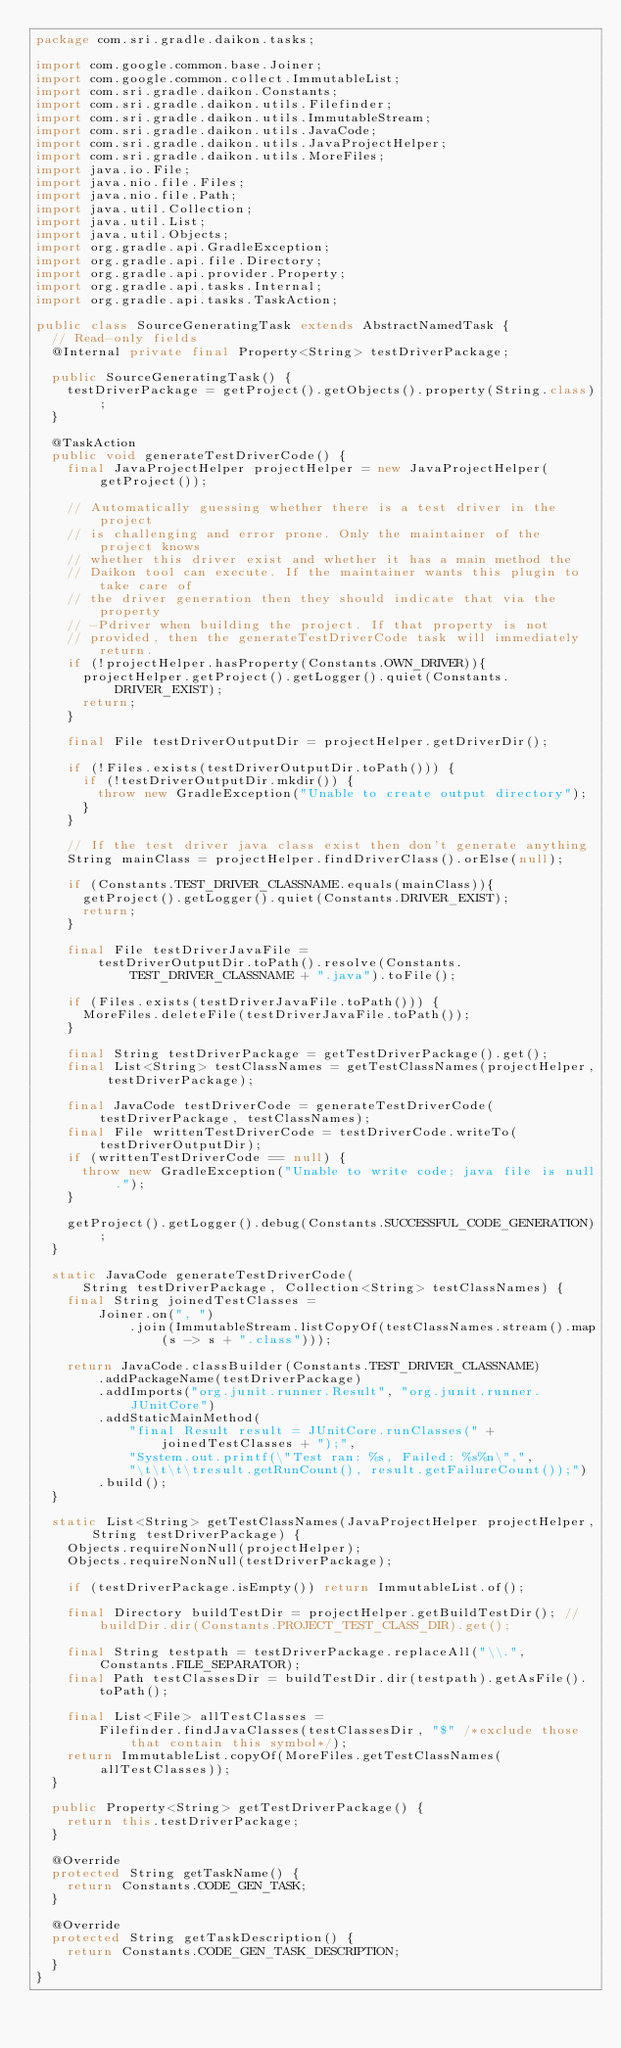<code> <loc_0><loc_0><loc_500><loc_500><_Java_>package com.sri.gradle.daikon.tasks;

import com.google.common.base.Joiner;
import com.google.common.collect.ImmutableList;
import com.sri.gradle.daikon.Constants;
import com.sri.gradle.daikon.utils.Filefinder;
import com.sri.gradle.daikon.utils.ImmutableStream;
import com.sri.gradle.daikon.utils.JavaCode;
import com.sri.gradle.daikon.utils.JavaProjectHelper;
import com.sri.gradle.daikon.utils.MoreFiles;
import java.io.File;
import java.nio.file.Files;
import java.nio.file.Path;
import java.util.Collection;
import java.util.List;
import java.util.Objects;
import org.gradle.api.GradleException;
import org.gradle.api.file.Directory;
import org.gradle.api.provider.Property;
import org.gradle.api.tasks.Internal;
import org.gradle.api.tasks.TaskAction;

public class SourceGeneratingTask extends AbstractNamedTask {
  // Read-only fields
  @Internal private final Property<String> testDriverPackage;

  public SourceGeneratingTask() {
    testDriverPackage = getProject().getObjects().property(String.class);
  }

  @TaskAction
  public void generateTestDriverCode() {
    final JavaProjectHelper projectHelper = new JavaProjectHelper(getProject());

    // Automatically guessing whether there is a test driver in the project
    // is challenging and error prone. Only the maintainer of the project knows
    // whether this driver exist and whether it has a main method the
    // Daikon tool can execute. If the maintainer wants this plugin to take care of
    // the driver generation then they should indicate that via the property
    // -Pdriver when building the project. If that property is not
    // provided, then the generateTestDriverCode task will immediately return.
    if (!projectHelper.hasProperty(Constants.OWN_DRIVER)){
      projectHelper.getProject().getLogger().quiet(Constants.DRIVER_EXIST);
      return;
    }

    final File testDriverOutputDir = projectHelper.getDriverDir();

    if (!Files.exists(testDriverOutputDir.toPath())) {
      if (!testDriverOutputDir.mkdir()) {
        throw new GradleException("Unable to create output directory");
      }
    }

    // If the test driver java class exist then don't generate anything
    String mainClass = projectHelper.findDriverClass().orElse(null);

    if (Constants.TEST_DRIVER_CLASSNAME.equals(mainClass)){
      getProject().getLogger().quiet(Constants.DRIVER_EXIST);
      return;
    }

    final File testDriverJavaFile =
        testDriverOutputDir.toPath().resolve(Constants.TEST_DRIVER_CLASSNAME + ".java").toFile();

    if (Files.exists(testDriverJavaFile.toPath())) {
      MoreFiles.deleteFile(testDriverJavaFile.toPath());
    }

    final String testDriverPackage = getTestDriverPackage().get();
    final List<String> testClassNames = getTestClassNames(projectHelper, testDriverPackage);

    final JavaCode testDriverCode = generateTestDriverCode(testDriverPackage, testClassNames);
    final File writtenTestDriverCode = testDriverCode.writeTo(testDriverOutputDir);
    if (writtenTestDriverCode == null) {
      throw new GradleException("Unable to write code; java file is null.");
    }

    getProject().getLogger().debug(Constants.SUCCESSFUL_CODE_GENERATION);
  }

  static JavaCode generateTestDriverCode(
      String testDriverPackage, Collection<String> testClassNames) {
    final String joinedTestClasses =
        Joiner.on(", ")
            .join(ImmutableStream.listCopyOf(testClassNames.stream().map(s -> s + ".class")));

    return JavaCode.classBuilder(Constants.TEST_DRIVER_CLASSNAME)
        .addPackageName(testDriverPackage)
        .addImports("org.junit.runner.Result", "org.junit.runner.JUnitCore")
        .addStaticMainMethod(
            "final Result result = JUnitCore.runClasses(" + joinedTestClasses + ");",
            "System.out.printf(\"Test ran: %s, Failed: %s%n\",",
            "\t\t\t\tresult.getRunCount(), result.getFailureCount());")
        .build();
  }

  static List<String> getTestClassNames(JavaProjectHelper projectHelper, String testDriverPackage) {
    Objects.requireNonNull(projectHelper);
    Objects.requireNonNull(testDriverPackage);

    if (testDriverPackage.isEmpty()) return ImmutableList.of();

    final Directory buildTestDir = projectHelper.getBuildTestDir(); // buildDir.dir(Constants.PROJECT_TEST_CLASS_DIR).get();

    final String testpath = testDriverPackage.replaceAll("\\.", Constants.FILE_SEPARATOR);
    final Path testClassesDir = buildTestDir.dir(testpath).getAsFile().toPath();

    final List<File> allTestClasses =
        Filefinder.findJavaClasses(testClassesDir, "$" /*exclude those that contain this symbol*/);
    return ImmutableList.copyOf(MoreFiles.getTestClassNames(allTestClasses));
  }

  public Property<String> getTestDriverPackage() {
    return this.testDriverPackage;
  }

  @Override
  protected String getTaskName() {
    return Constants.CODE_GEN_TASK;
  }

  @Override
  protected String getTaskDescription() {
    return Constants.CODE_GEN_TASK_DESCRIPTION;
  }
}
</code> 